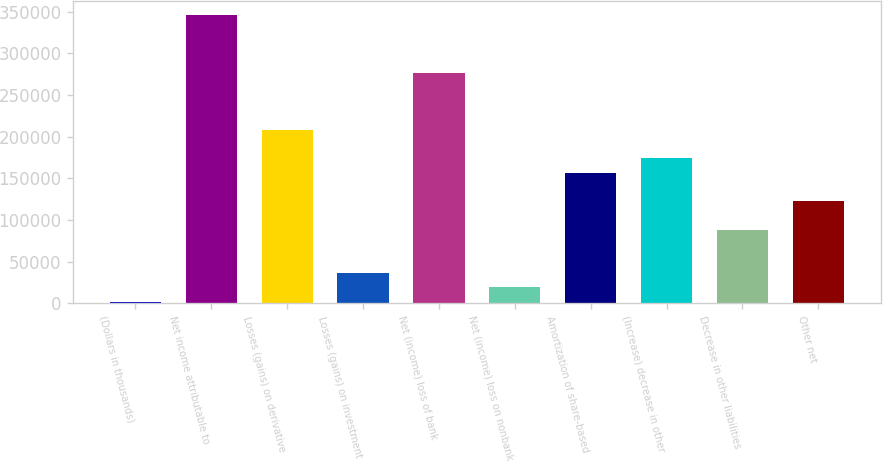Convert chart. <chart><loc_0><loc_0><loc_500><loc_500><bar_chart><fcel>(Dollars in thousands)<fcel>Net income attributable to<fcel>Losses (gains) on derivative<fcel>Losses (gains) on investment<fcel>Net (income) loss of bank<fcel>Net (income) loss on nonbank<fcel>Amortization of share-based<fcel>(Increase) decrease in other<fcel>Decrease in other liabilities<fcel>Other net<nl><fcel>2007<fcel>345563<fcel>208141<fcel>36362.6<fcel>276852<fcel>19184.8<fcel>156607<fcel>173785<fcel>87896<fcel>122252<nl></chart> 